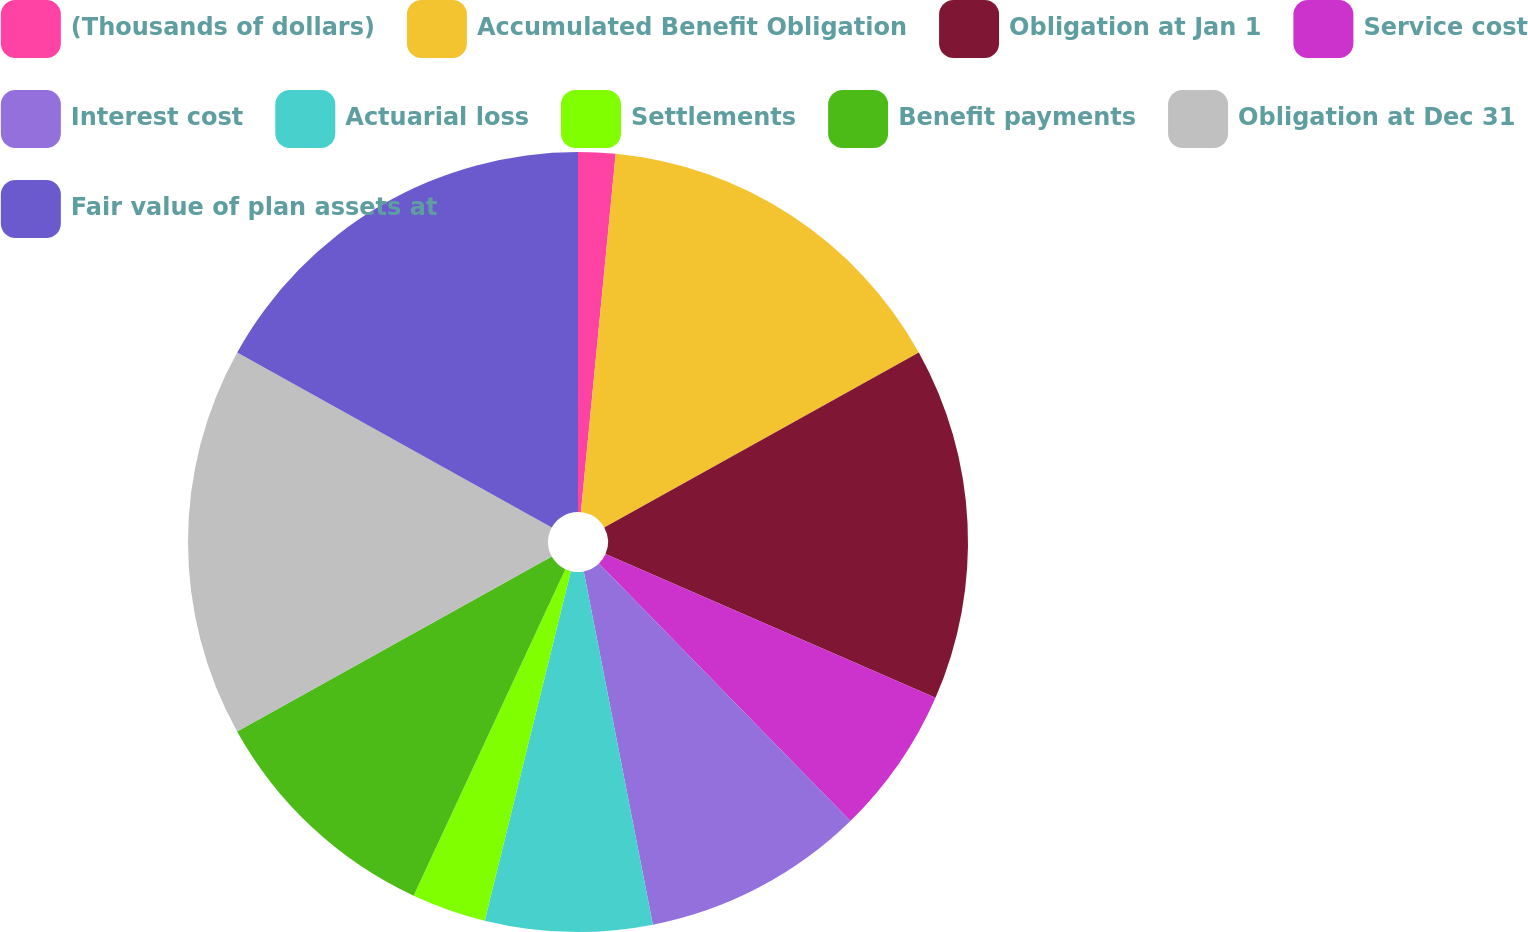Convert chart. <chart><loc_0><loc_0><loc_500><loc_500><pie_chart><fcel>(Thousands of dollars)<fcel>Accumulated Benefit Obligation<fcel>Obligation at Jan 1<fcel>Service cost<fcel>Interest cost<fcel>Actuarial loss<fcel>Settlements<fcel>Benefit payments<fcel>Obligation at Dec 31<fcel>Fair value of plan assets at<nl><fcel>1.54%<fcel>15.38%<fcel>14.62%<fcel>6.15%<fcel>9.23%<fcel>6.92%<fcel>3.08%<fcel>10.0%<fcel>16.15%<fcel>16.92%<nl></chart> 